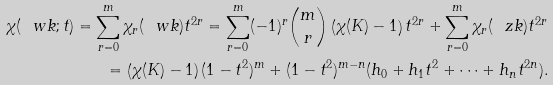<formula> <loc_0><loc_0><loc_500><loc_500>\chi ( \ w k ; t ) = \sum _ { r = 0 } ^ { m } \chi _ { r } ( \ w k ) t ^ { 2 r } = \sum _ { r = 0 } ^ { m } ( - 1 ) ^ { r } { \binom { m } { r } } \left ( \chi ( K ) - 1 \right ) t ^ { 2 r } + \sum _ { r = 0 } ^ { m } \chi _ { r } ( \ z k ) t ^ { 2 r } \\ = \left ( \chi ( K ) - 1 \right ) ( 1 - t ^ { 2 } ) ^ { m } + ( 1 - t ^ { 2 } ) ^ { m - n } ( h _ { 0 } + h _ { 1 } t ^ { 2 } + \cdots + h _ { n } t ^ { 2 n } ) .</formula> 